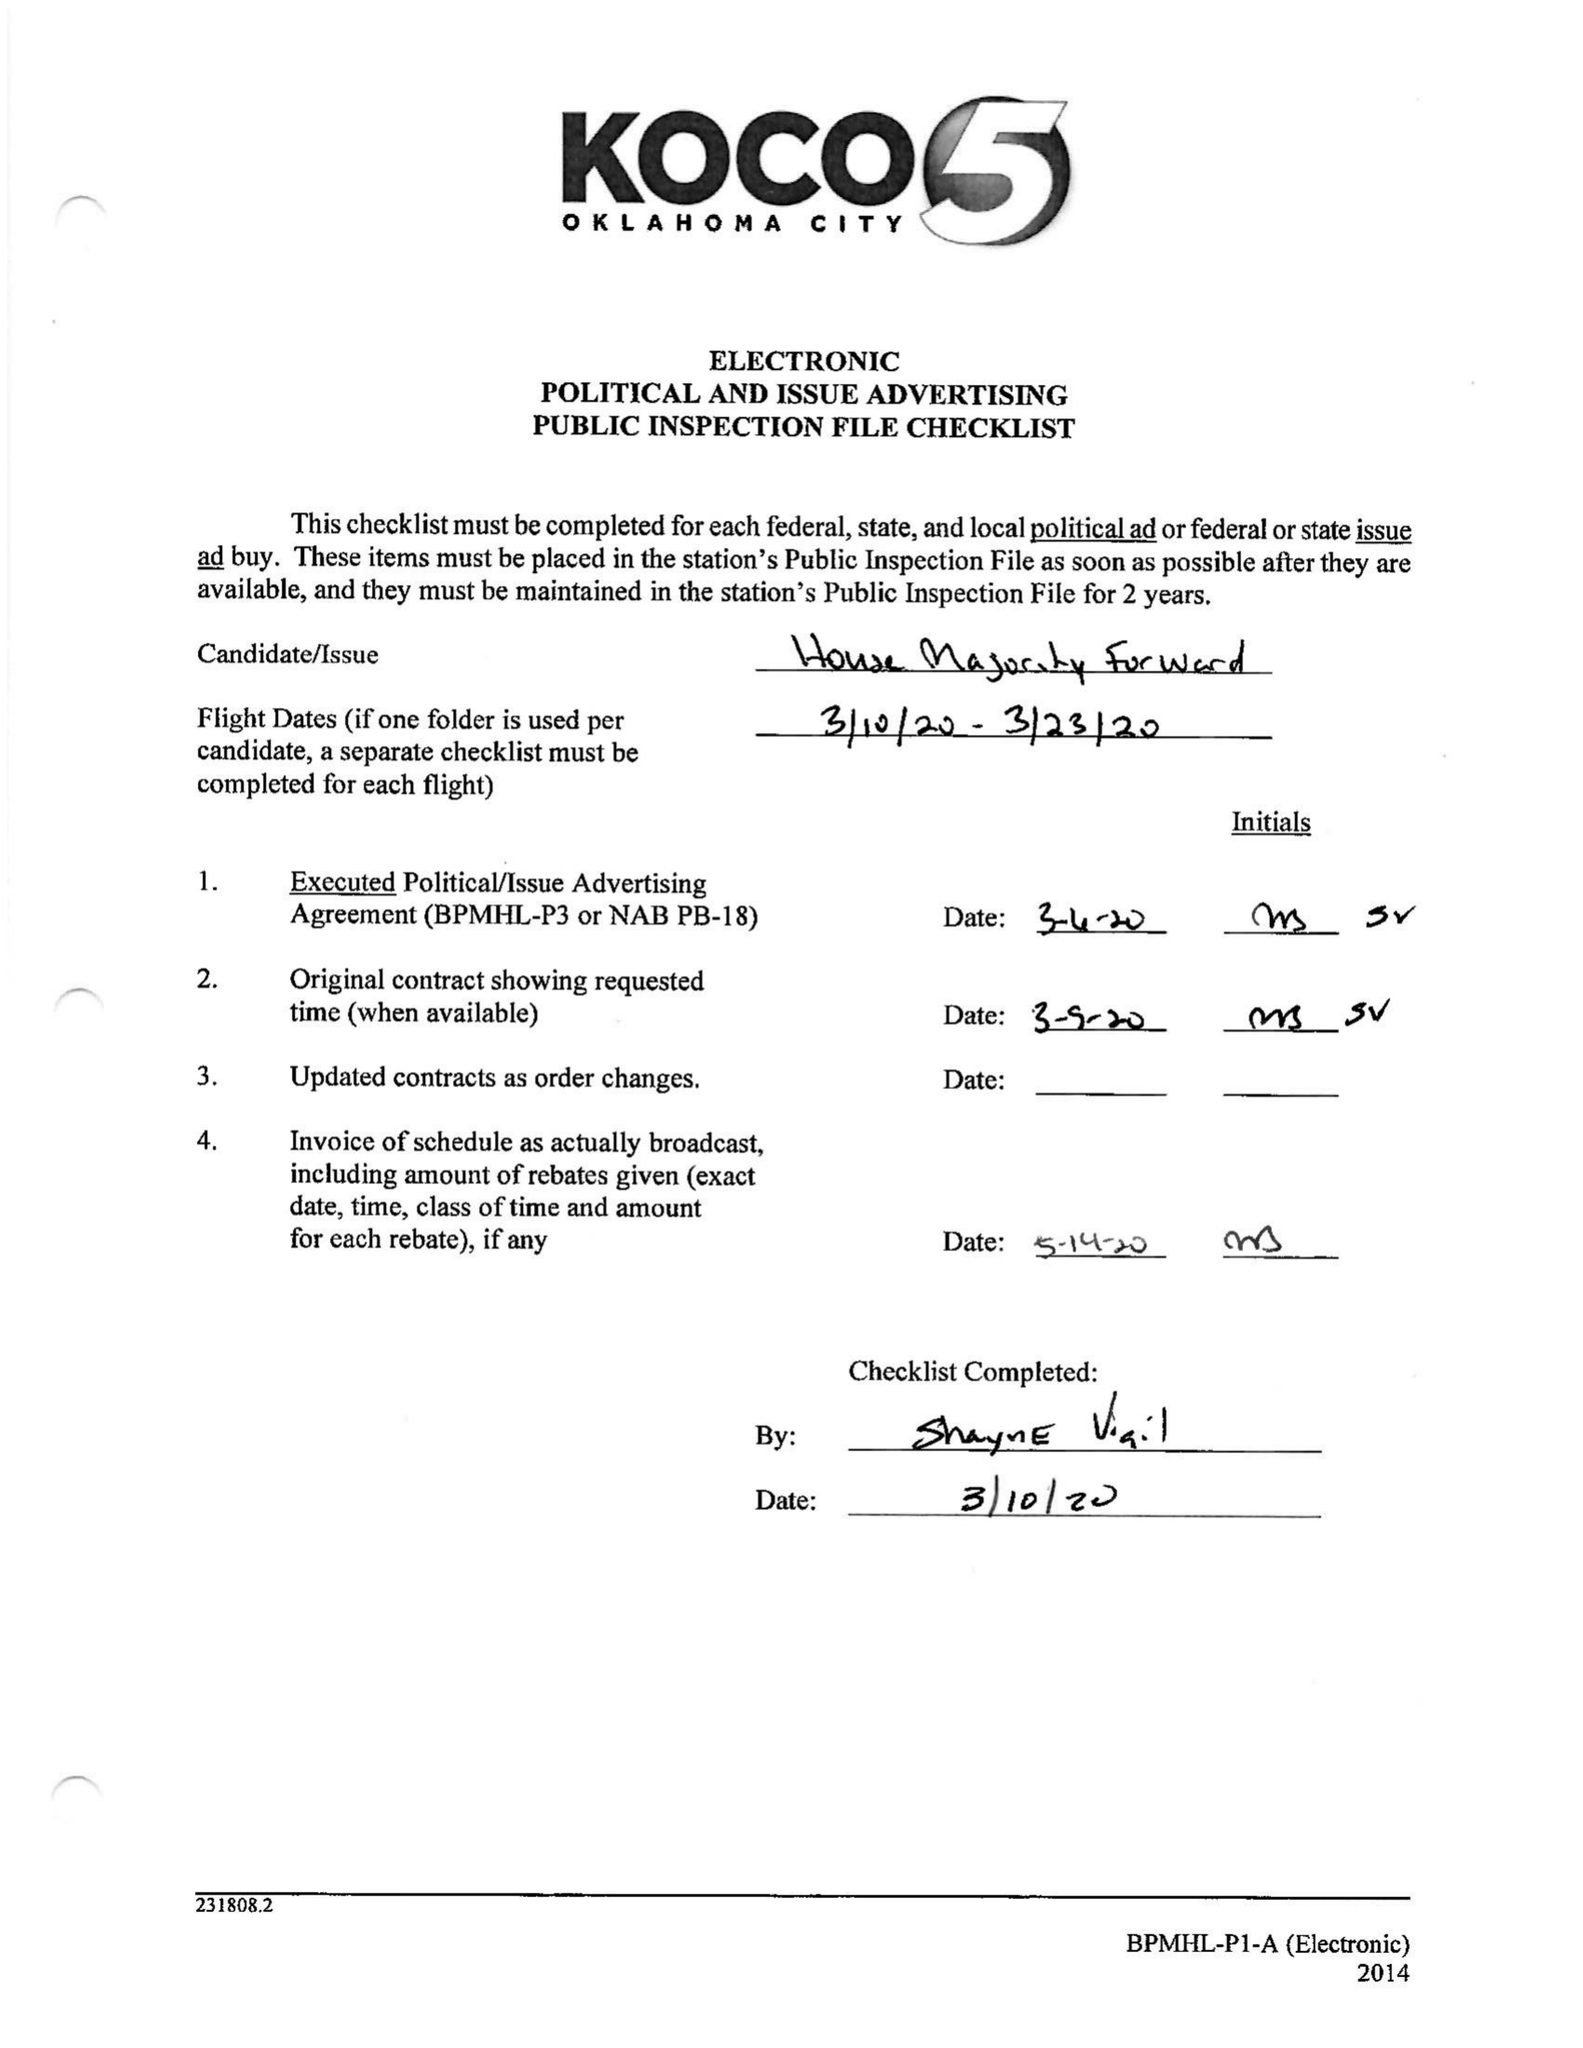What is the value for the advertiser?
Answer the question using a single word or phrase. HOUSE MAJORITY FORWARD 